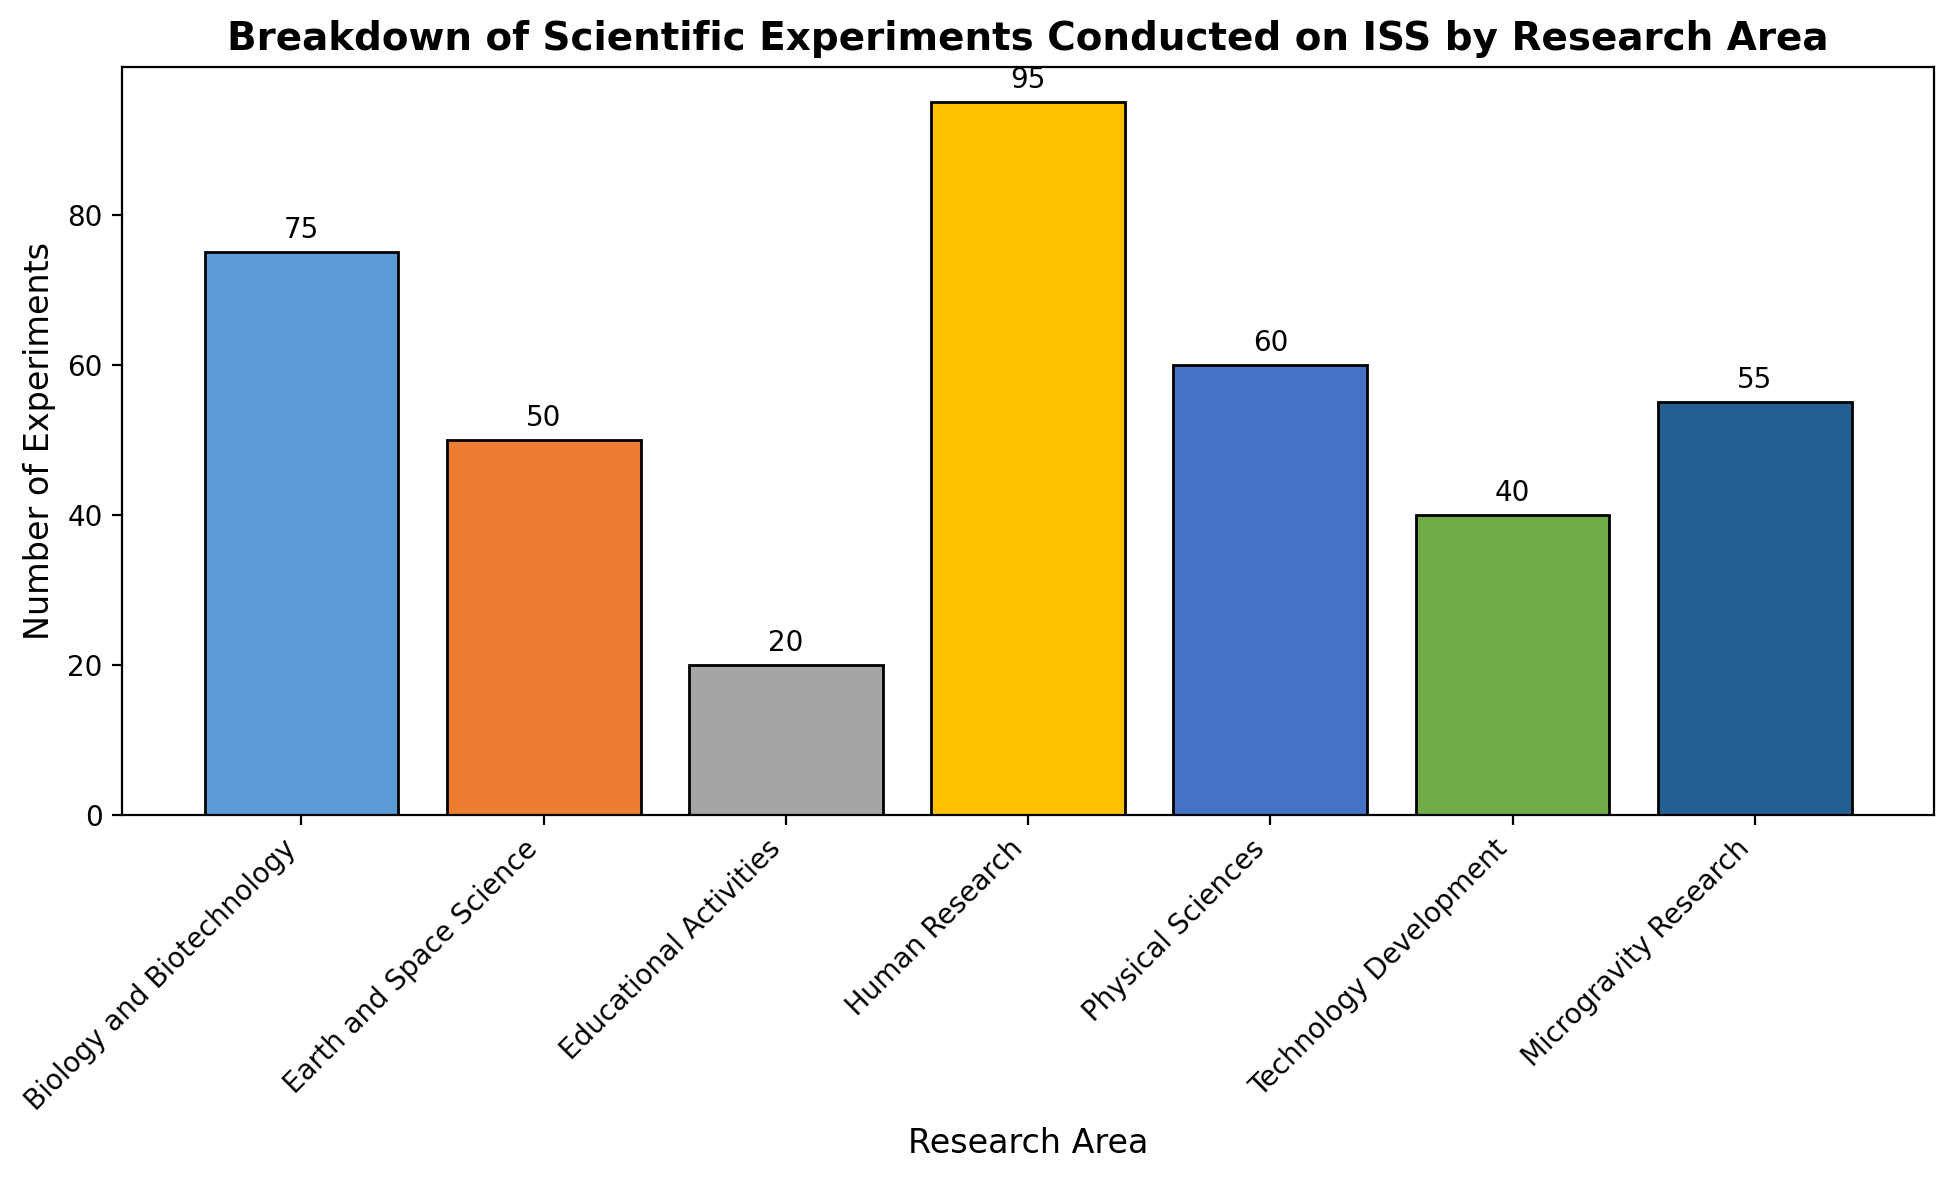Which research area has the highest number of experiments? To find the research area with the highest number of experiments, look at the bar with the greatest height. The "Human Research" bar is the tallest.
Answer: Human Research Which research area has the lowest number of experiments? To find the research area with the fewest experiments, look at the bar with the shortest height. The "Educational Activities" bar is the shortest.
Answer: Educational Activities How many more experiments are conducted in Human Research compared to Educational Activities? The number of experiments in Human Research is 95, and in Educational Activities, it is 20. The difference is 95 - 20.
Answer: 75 What is the total number of experiments conducted in Earth and Space Science and Physical Sciences? The number of experiments in Earth and Space Science is 50, and in Physical Sciences, it is 60. The total is 50 + 60.
Answer: 110 Which research area has exactly 55 experiments? Check the bars with labels. The "Microgravity Research" bar is labeled with 55.
Answer: Microgravity Research Are there more experiments in Technology Development or Biology and Biotechnology? The number of experiments in Biology and Biotechnology is 75, while in Technology Development it is 40. Compare the two: 75 > 40.
Answer: Biology and Biotechnology What is the average number of experiments conducted in all research areas? Sum the number of experiments for all areas: 75 + 50 + 20 + 95 + 60 + 40 + 55 = 395. There are 7 research areas, so the average is 395 / 7.
Answer: 56.43 What is the difference between the number of experiments in Human Research and Microgravity Research? The number of experiments in Human Research is 95, and in Microgravity Research it is 55. The difference is 95 - 55.
Answer: 40 How many experiments are conducted across all research areas combined? Sum the number of experiments for all areas: 75 + 50 + 20 + 95 + 60 + 40 + 55.
Answer: 395 